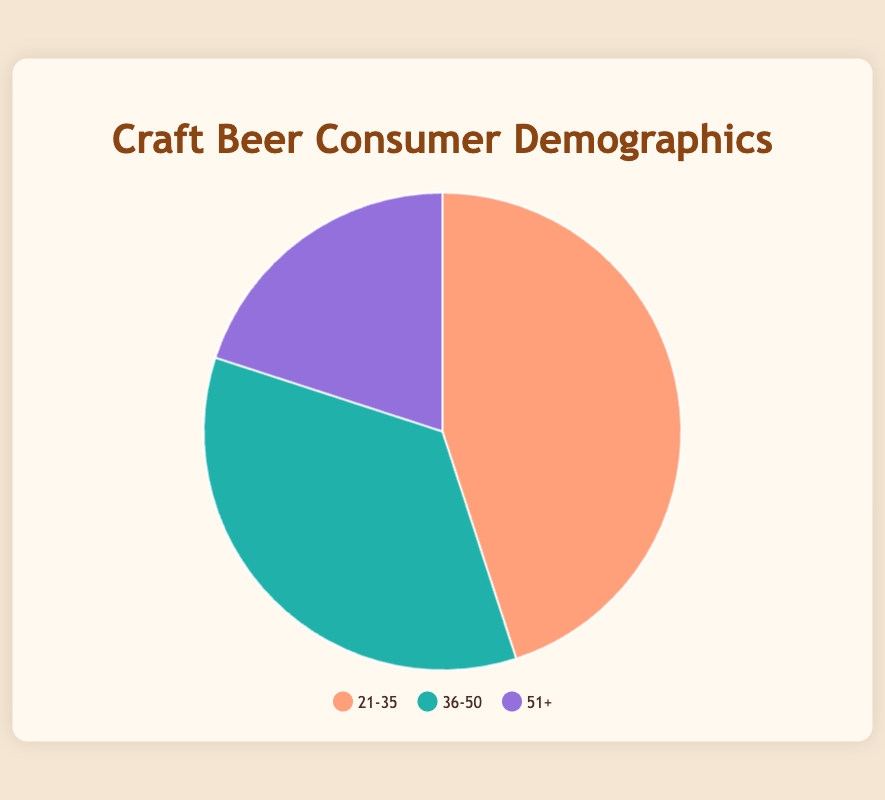What's the largest demographic group of craft beer consumers? The pie chart shows three age groups: 21-35, 36-50, and 51+. The 21-35 age group has the largest percentage, 45%.
Answer: 21-35 Which group represents one-third of the consumer base? The age group 36-50 represents 35% of the total, which is close to one-third of 100%.
Answer: 36-50 What's the combined percentage of consumers aged 36-50 and 51+? The chart shows that consumers aged 36-50 account for 35% and those aged 51+ account for 20%. Adding these together: 35% + 20% = 55%.
Answer: 55% Which age group prefers companies like Stone Brewing and Founders Brewing? Stone Brewing and Founders Brewing are listed under the 36-50 age group.
Answer: 36-50 What is the difference in the percentage of consumers between the youngest and oldest age groups? The youngest age group (21-35) is 45% and the oldest (51+) is 20%. The difference is 45% - 20% = 25%.
Answer: 25% Which color represents the 51+ age group in the pie chart? The legend shows that the 51+ age group is represented by a purple color.
Answer: Purple What's the percentage of consumers aged 21-50? The age groups 21-35 and 36-50 together make up the 21-50 range. Adding their percentages: 45% + 35% = 80%.
Answer: 80% Compare the percentage of consumers in the 21-35 age group to those in 36-50. Which is larger and by how much? The 21-35 age group is 45% and the 36-50 group is 35%. The 21-35 group is larger by 45% - 35% = 10%.
Answer: 21-35, 10% If the company's goal was to target 70% of the market, which age groups should they focus on? Combining the percentages of the 21-35 (45%) and 36-50 (35%) age groups covers 45% + 35% = 80%, which exceeds the 70% target.
Answer: 21-35 and 36-50 